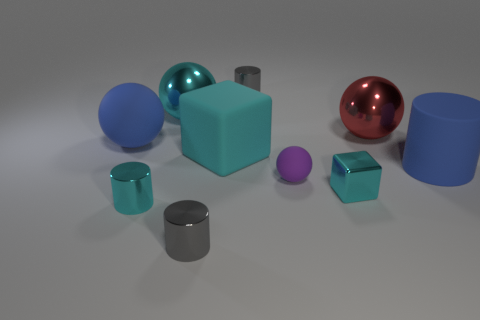What can you infer about the size of the objects? The objects vary in size, with the cyan cube being the largest. Relative sizes suggest the small purple ball is the smallest item, and the rest fall in between, with cylinders and spheres varying moderately in size. 